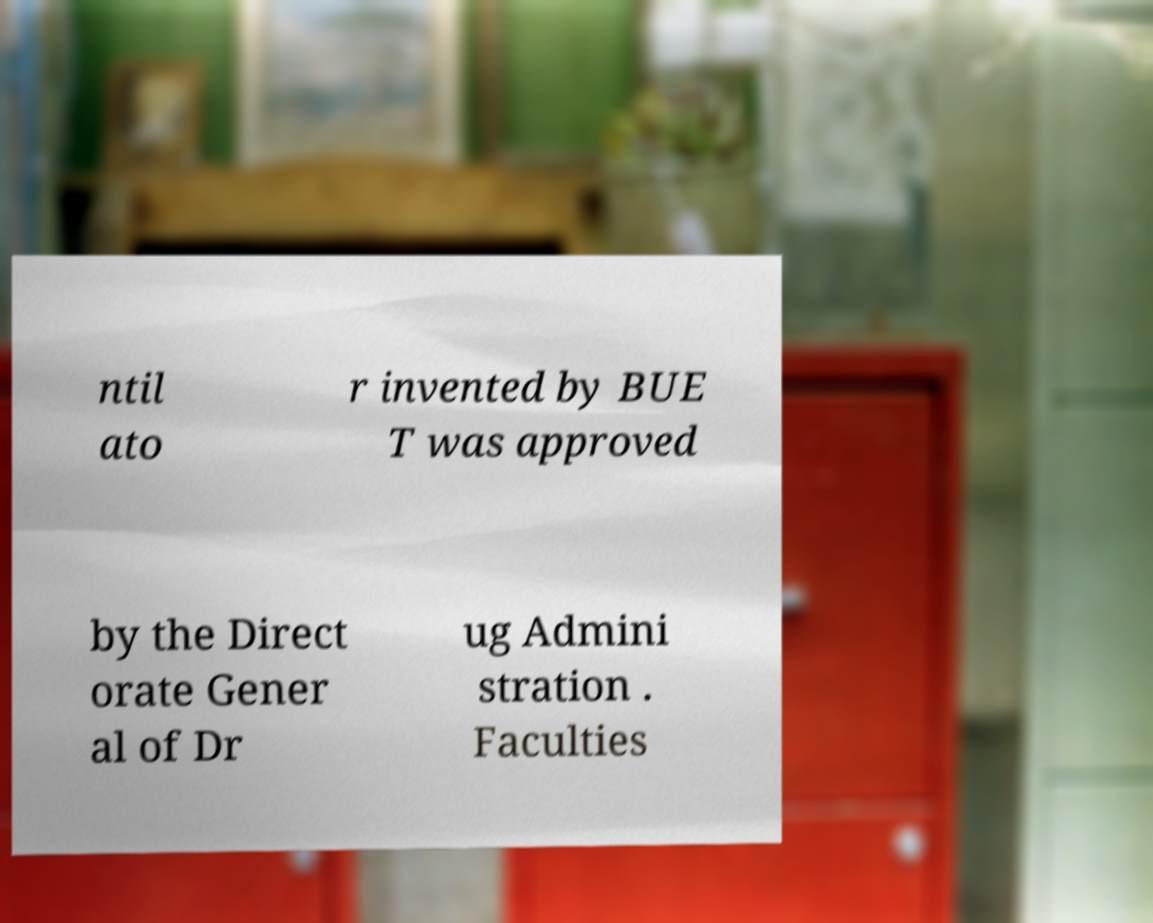For documentation purposes, I need the text within this image transcribed. Could you provide that? ntil ato r invented by BUE T was approved by the Direct orate Gener al of Dr ug Admini stration . Faculties 